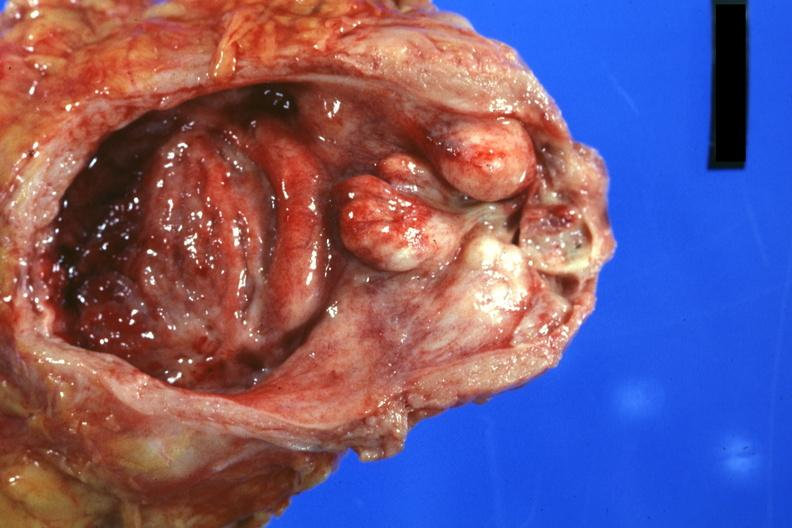what is present?
Answer the question using a single word or phrase. Benign hyperplasia 